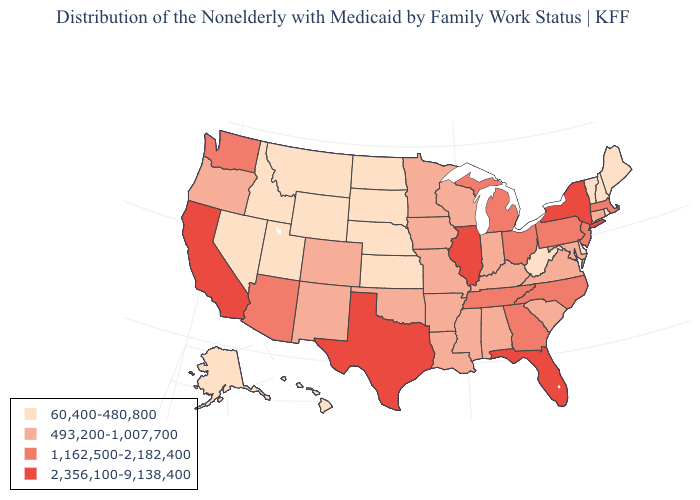Among the states that border Mississippi , does Alabama have the lowest value?
Be succinct. Yes. Name the states that have a value in the range 60,400-480,800?
Keep it brief. Alaska, Delaware, Hawaii, Idaho, Kansas, Maine, Montana, Nebraska, Nevada, New Hampshire, North Dakota, Rhode Island, South Dakota, Utah, Vermont, West Virginia, Wyoming. Which states have the lowest value in the South?
Short answer required. Delaware, West Virginia. Which states have the highest value in the USA?
Give a very brief answer. California, Florida, Illinois, New York, Texas. Does the first symbol in the legend represent the smallest category?
Be succinct. Yes. What is the value of Nebraska?
Give a very brief answer. 60,400-480,800. Which states have the highest value in the USA?
Short answer required. California, Florida, Illinois, New York, Texas. Does Massachusetts have a higher value than New York?
Answer briefly. No. What is the highest value in the USA?
Answer briefly. 2,356,100-9,138,400. Which states have the highest value in the USA?
Be succinct. California, Florida, Illinois, New York, Texas. What is the value of Pennsylvania?
Answer briefly. 1,162,500-2,182,400. What is the value of New Hampshire?
Write a very short answer. 60,400-480,800. What is the highest value in the Northeast ?
Write a very short answer. 2,356,100-9,138,400. What is the value of South Dakota?
Be succinct. 60,400-480,800. Name the states that have a value in the range 2,356,100-9,138,400?
Concise answer only. California, Florida, Illinois, New York, Texas. 